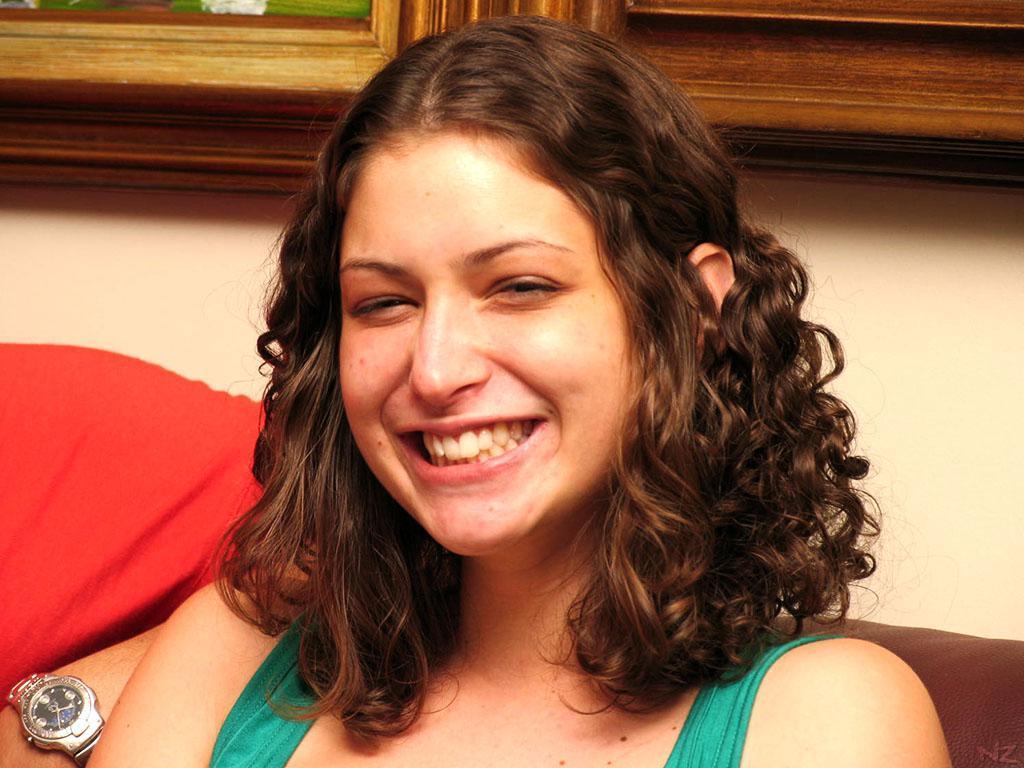How would you summarize this image in a sentence or two? In this image I can see a woman laughing. 